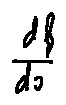<formula> <loc_0><loc_0><loc_500><loc_500>\frac { d f } { d x }</formula> 